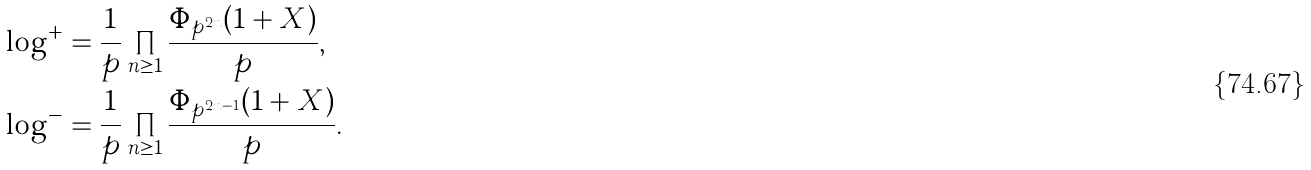Convert formula to latex. <formula><loc_0><loc_0><loc_500><loc_500>\log ^ { + } & = \frac { 1 } { p } \prod _ { n \geq 1 } \frac { \Phi _ { p ^ { 2 n } } ( 1 + X ) } { p } , \\ \log ^ { - } & = \frac { 1 } { p } \prod _ { n \geq 1 } \frac { \Phi _ { p ^ { 2 n - 1 } } ( 1 + X ) } { p } .</formula> 